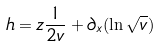Convert formula to latex. <formula><loc_0><loc_0><loc_500><loc_500>h = z \frac { 1 } { 2 v } + \partial _ { x } ( \ln \sqrt { v } )</formula> 